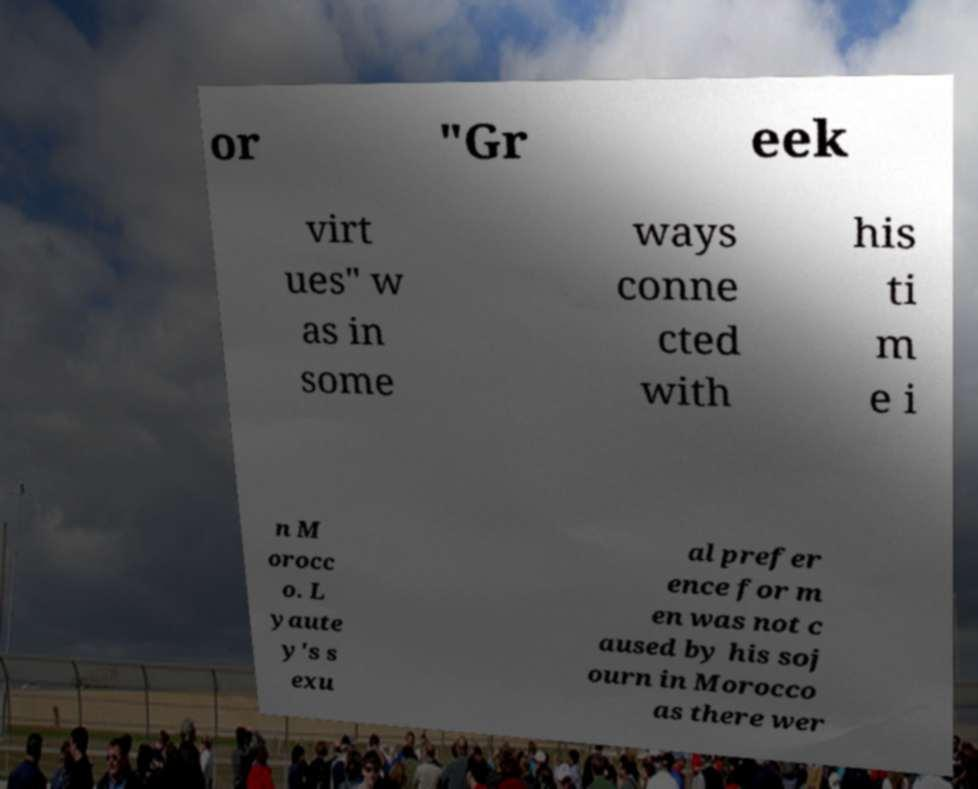I need the written content from this picture converted into text. Can you do that? or "Gr eek virt ues" w as in some ways conne cted with his ti m e i n M orocc o. L yaute y's s exu al prefer ence for m en was not c aused by his soj ourn in Morocco as there wer 